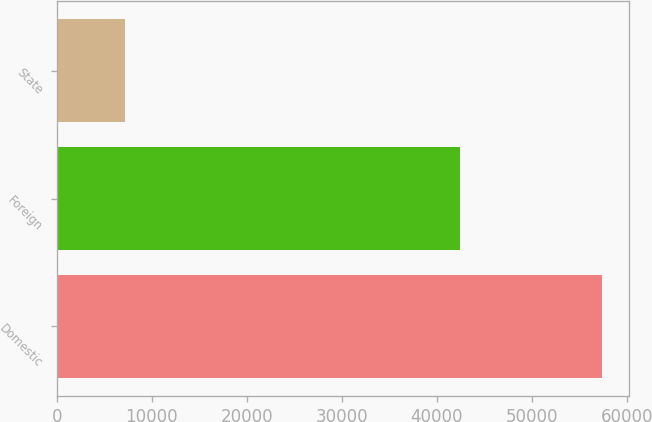<chart> <loc_0><loc_0><loc_500><loc_500><bar_chart><fcel>Domestic<fcel>Foreign<fcel>State<nl><fcel>57378<fcel>42446<fcel>7214<nl></chart> 